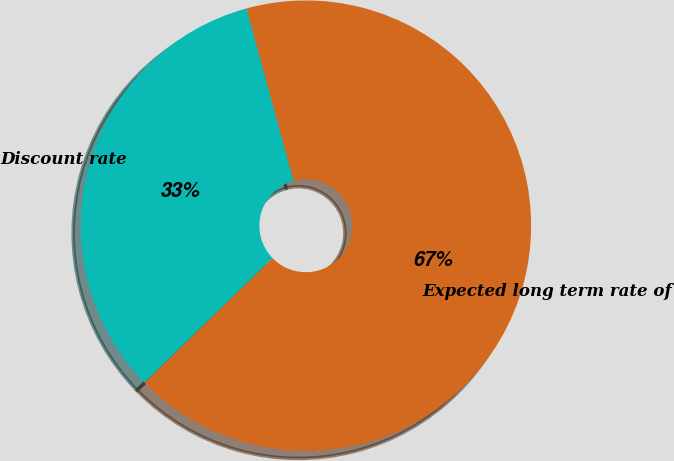Convert chart to OTSL. <chart><loc_0><loc_0><loc_500><loc_500><pie_chart><fcel>Discount rate<fcel>Expected long term rate of<nl><fcel>33.04%<fcel>66.96%<nl></chart> 